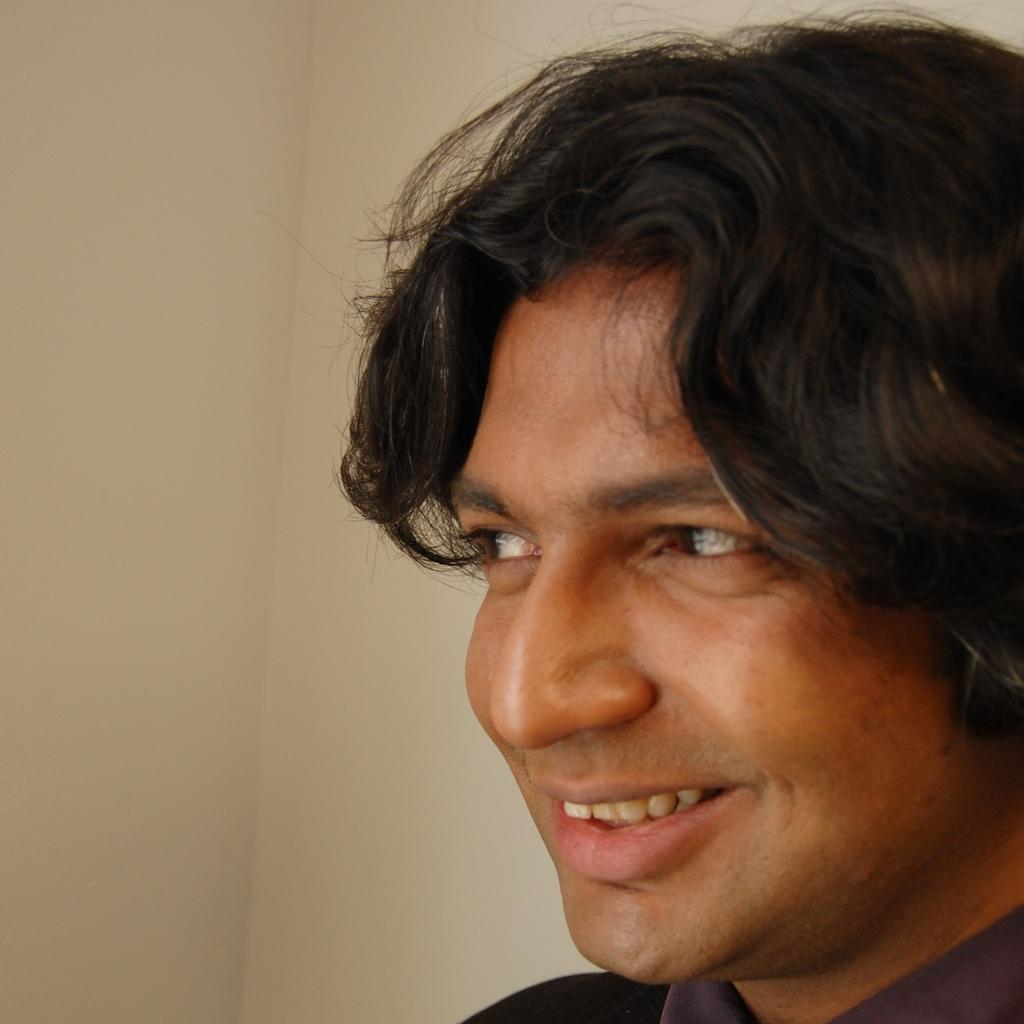What is the main subject of the image? There is a man in the image. What is the man doing in the image? The man is laughing. What can be seen behind the man in the image? There is a wall behind the man. How many pizzas can be seen on the man's head in the image? There are no pizzas present in the image, and the man's head is not visible. 